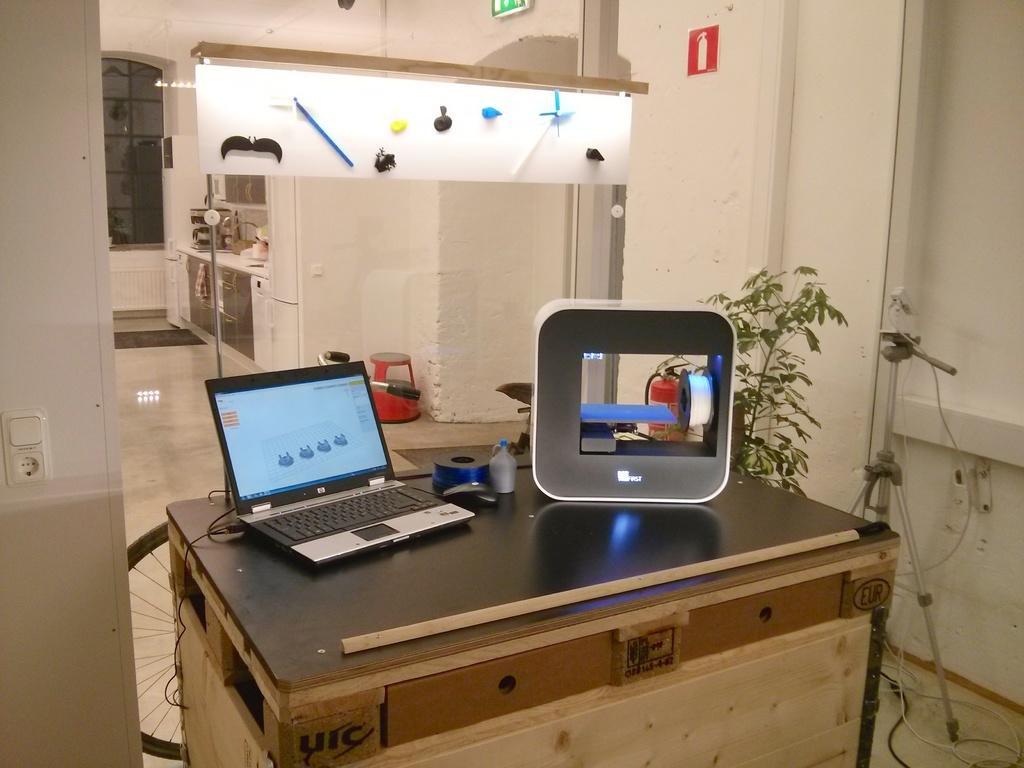Please provide a concise description of this image. In this image i can see a table with a laptop and other objects on it. I can also see there is white plant and white wall. 